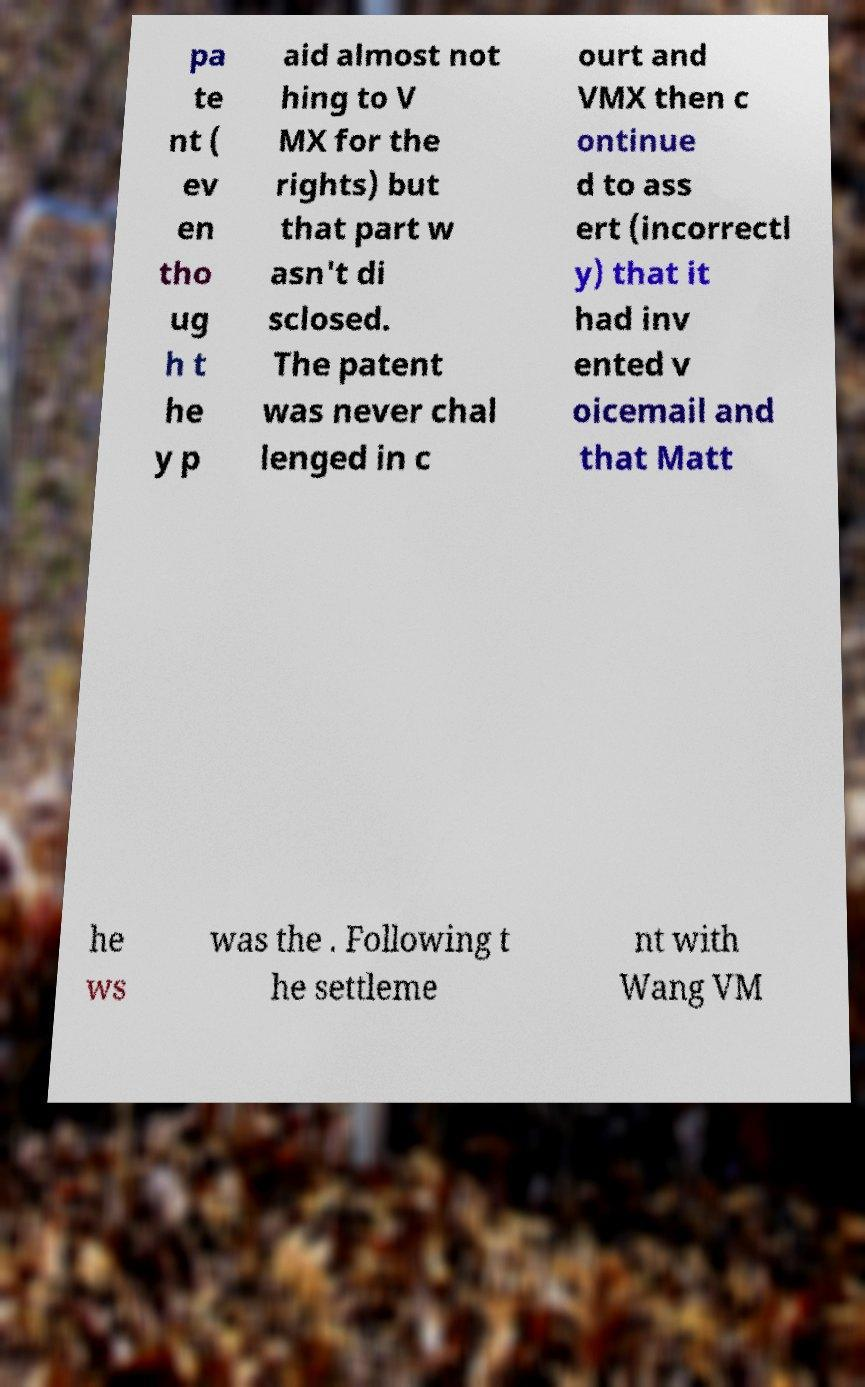Please read and relay the text visible in this image. What does it say? pa te nt ( ev en tho ug h t he y p aid almost not hing to V MX for the rights) but that part w asn't di sclosed. The patent was never chal lenged in c ourt and VMX then c ontinue d to ass ert (incorrectl y) that it had inv ented v oicemail and that Matt he ws was the . Following t he settleme nt with Wang VM 